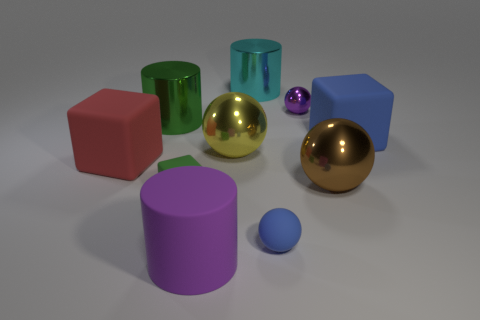Can you describe the lighting in the image? The lighting in the image seems to be soft and diffused, suggesting an indirect light source. It creates gentle shadows and gives the scene a calm, ambient feel. 